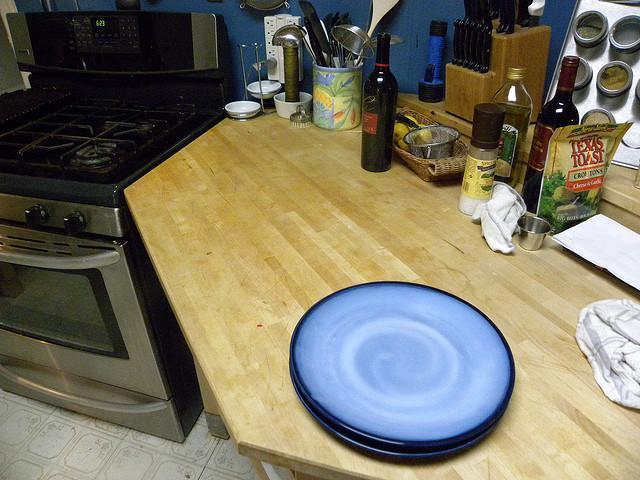How many people will eat on these plates?
Give a very brief answer. 2. How many bottles are visible?
Give a very brief answer. 3. 